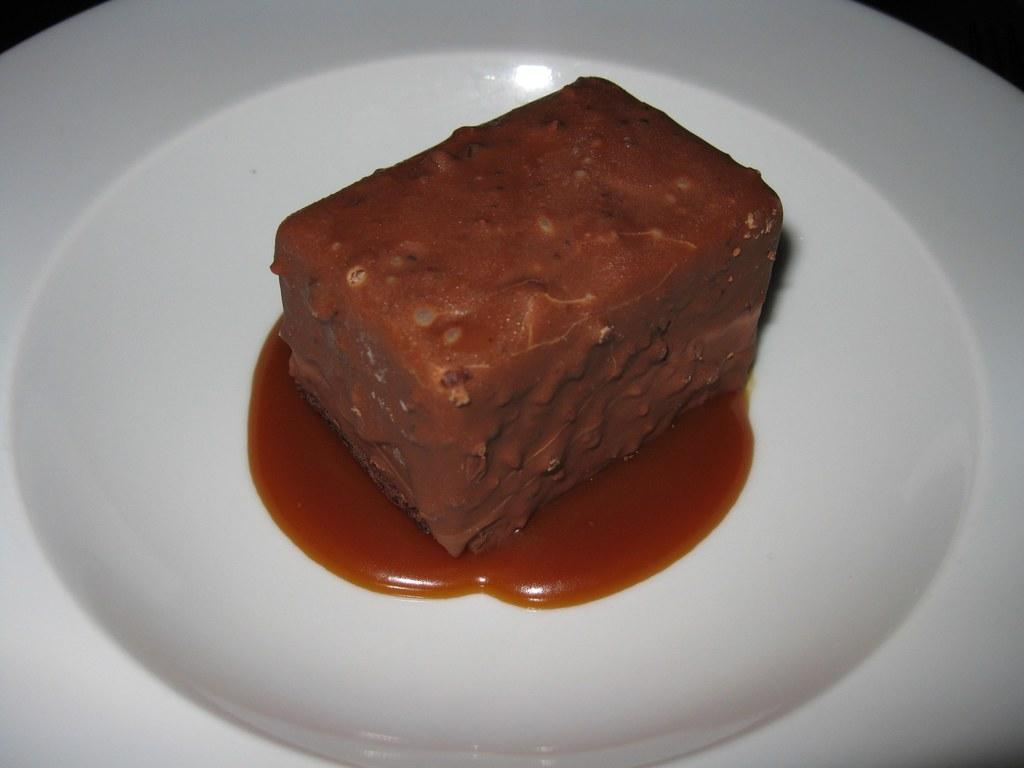What is the main subject in the center of the image? There is a desert on a plate in the center of the image. What type of cakes can be seen in the image? There are no cakes present in the image; it features a desert on a plate. What does the desert smell like in the image? The image does not provide information about the smell of the desert. Is there a lamp visible in the image? There is no lamp present in the image. 